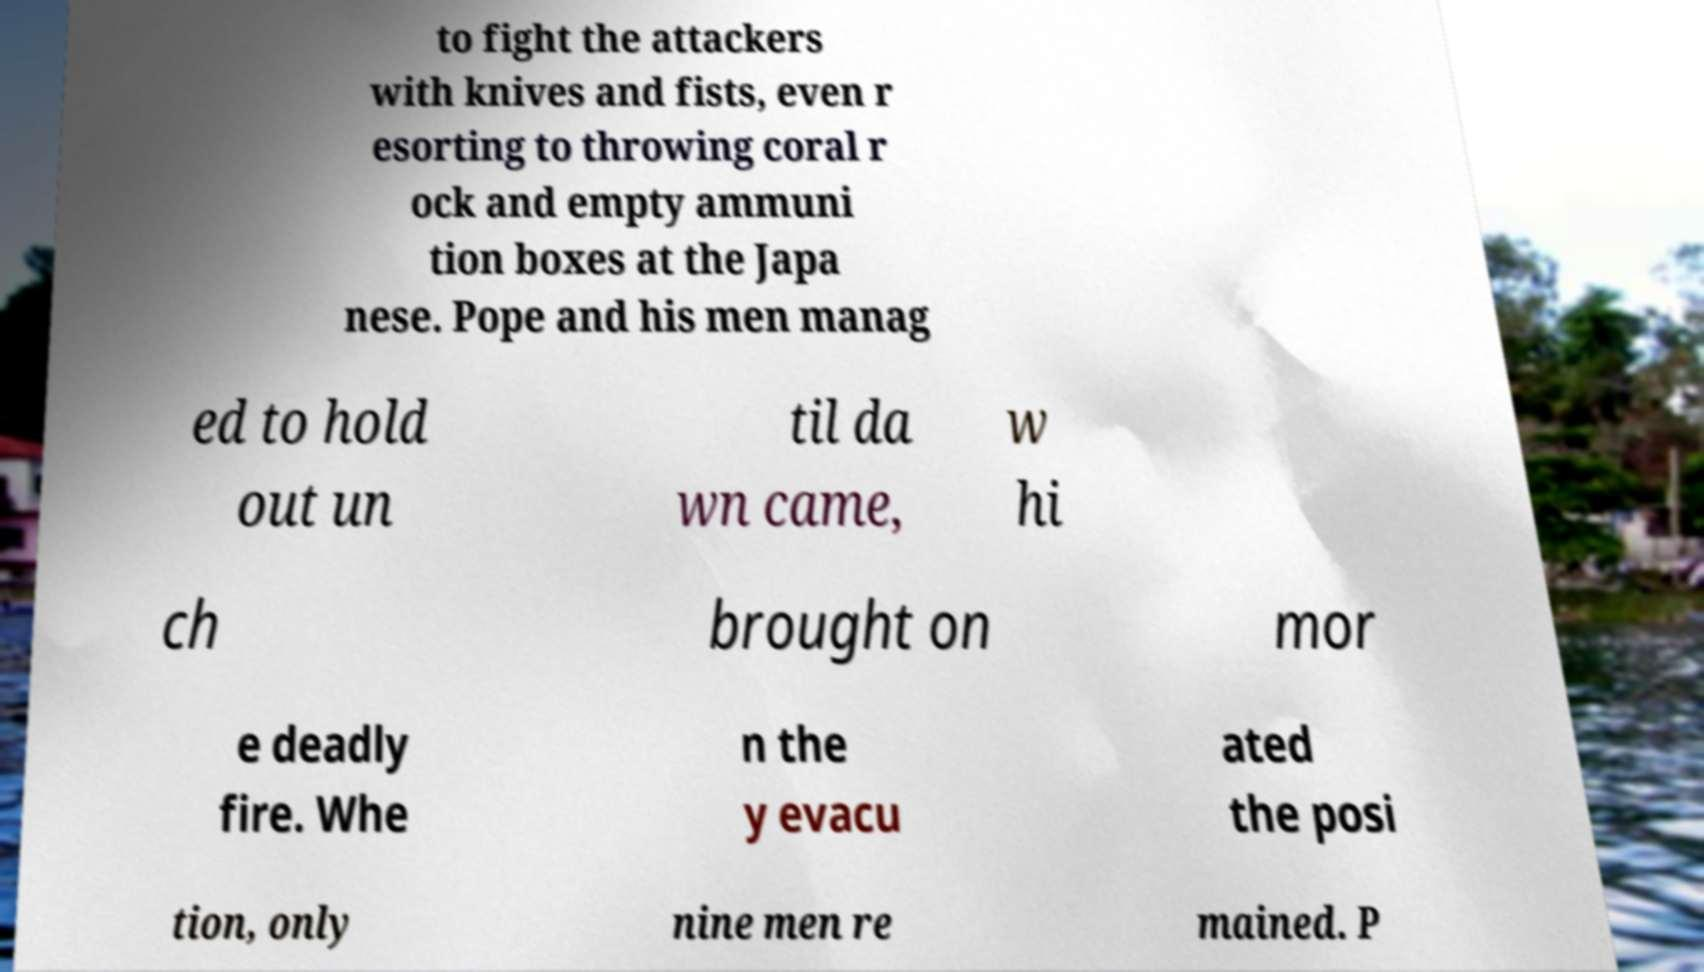I need the written content from this picture converted into text. Can you do that? to fight the attackers with knives and fists, even r esorting to throwing coral r ock and empty ammuni tion boxes at the Japa nese. Pope and his men manag ed to hold out un til da wn came, w hi ch brought on mor e deadly fire. Whe n the y evacu ated the posi tion, only nine men re mained. P 